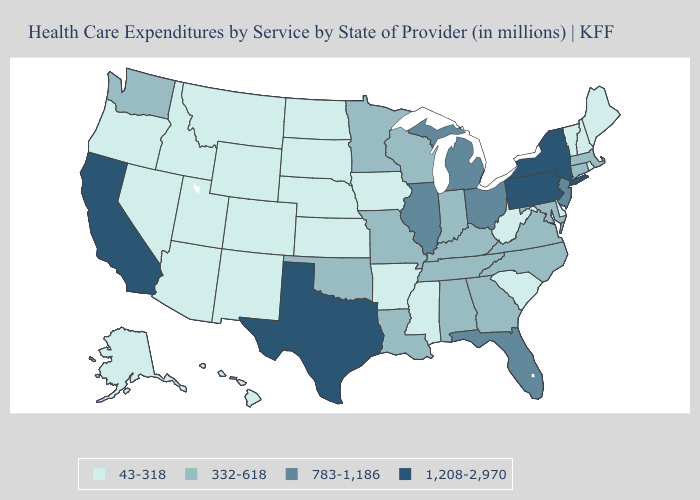What is the highest value in the USA?
Short answer required. 1,208-2,970. What is the lowest value in the Northeast?
Keep it brief. 43-318. Does the first symbol in the legend represent the smallest category?
Quick response, please. Yes. Name the states that have a value in the range 332-618?
Give a very brief answer. Alabama, Connecticut, Georgia, Indiana, Kentucky, Louisiana, Maryland, Massachusetts, Minnesota, Missouri, North Carolina, Oklahoma, Tennessee, Virginia, Washington, Wisconsin. Which states hav the highest value in the Northeast?
Short answer required. New York, Pennsylvania. What is the highest value in the USA?
Give a very brief answer. 1,208-2,970. What is the value of Iowa?
Quick response, please. 43-318. How many symbols are there in the legend?
Short answer required. 4. What is the value of Illinois?
Be succinct. 783-1,186. What is the lowest value in the West?
Write a very short answer. 43-318. How many symbols are there in the legend?
Short answer required. 4. Which states have the lowest value in the South?
Keep it brief. Arkansas, Delaware, Mississippi, South Carolina, West Virginia. How many symbols are there in the legend?
Keep it brief. 4. Name the states that have a value in the range 783-1,186?
Give a very brief answer. Florida, Illinois, Michigan, New Jersey, Ohio. 